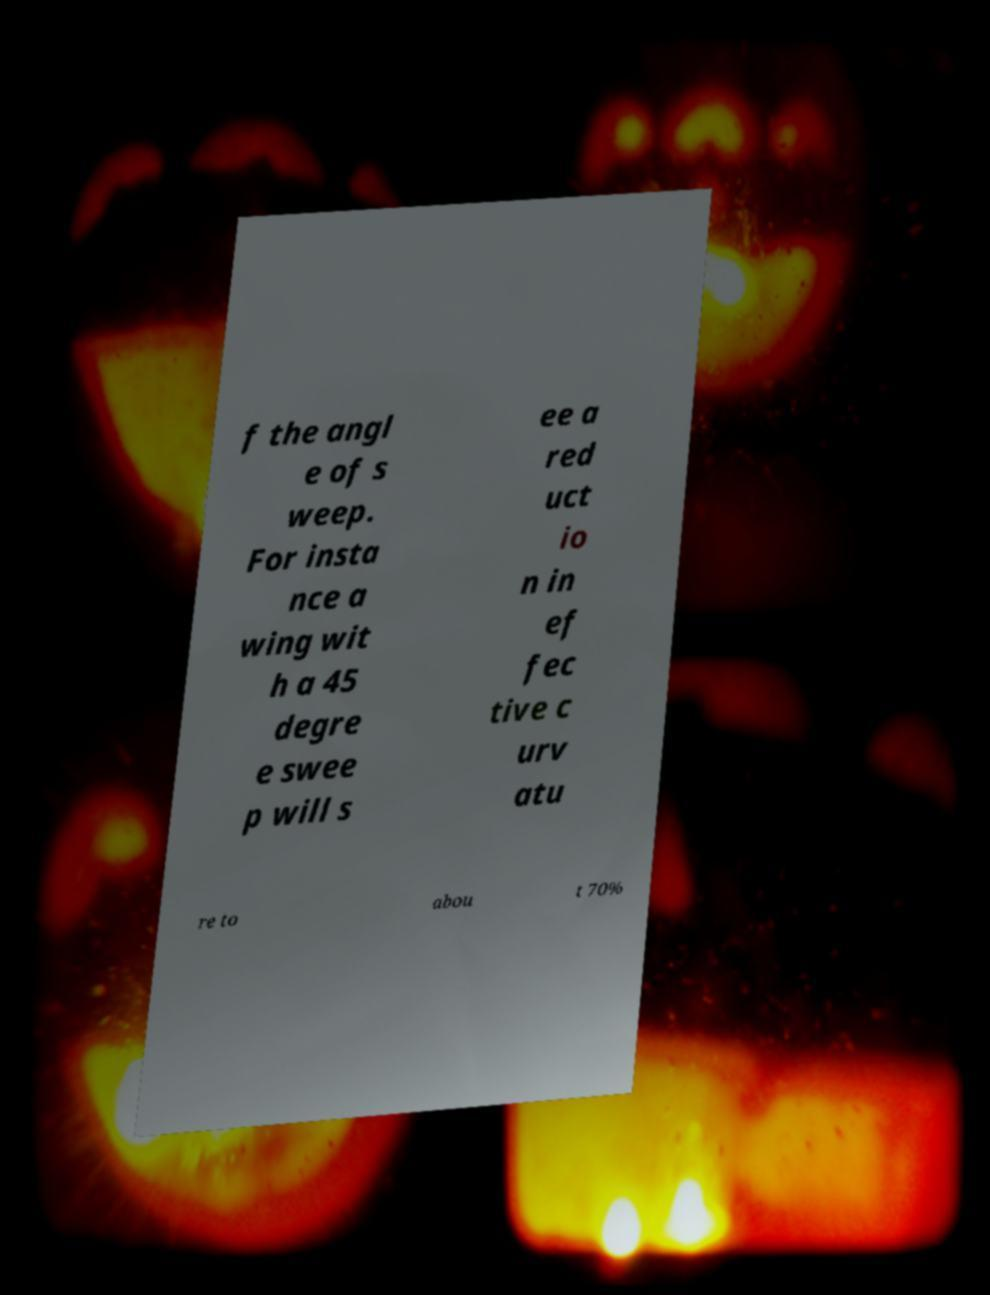For documentation purposes, I need the text within this image transcribed. Could you provide that? f the angl e of s weep. For insta nce a wing wit h a 45 degre e swee p will s ee a red uct io n in ef fec tive c urv atu re to abou t 70% 